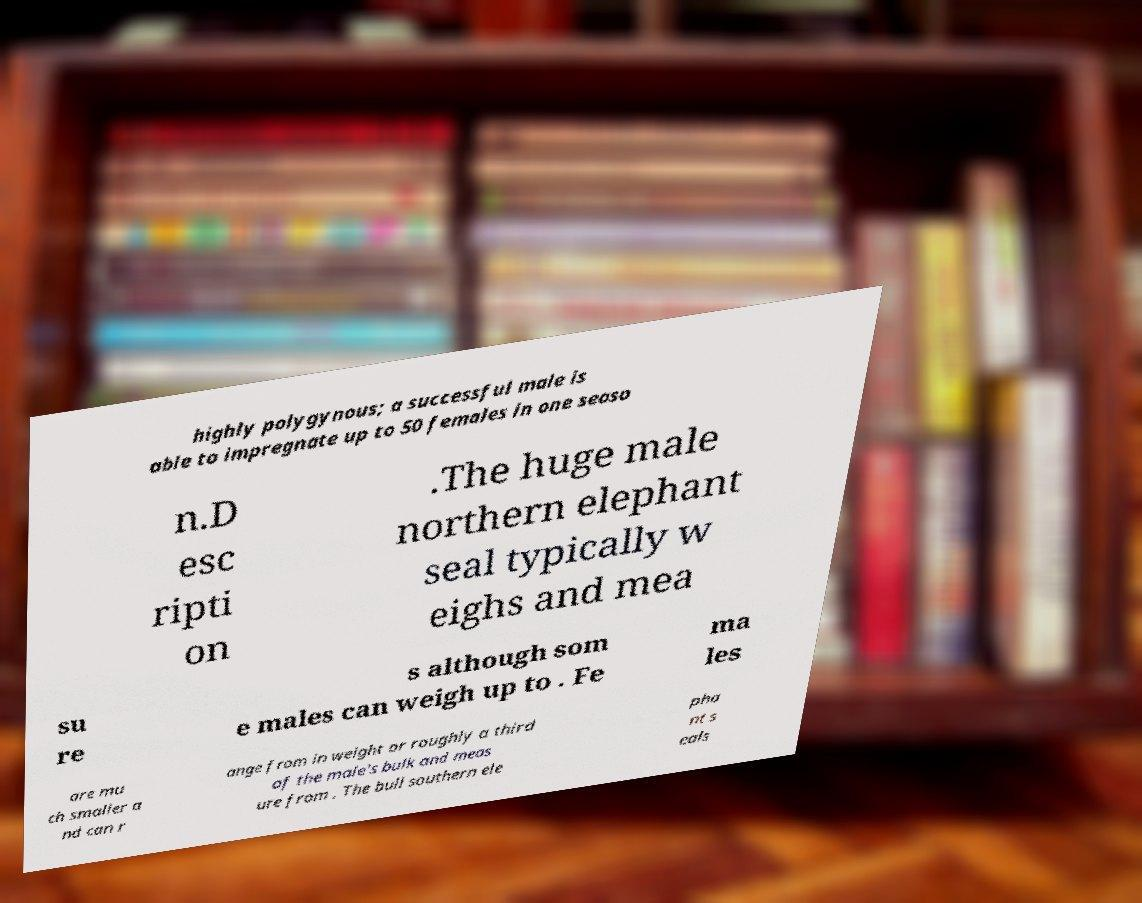Please identify and transcribe the text found in this image. highly polygynous; a successful male is able to impregnate up to 50 females in one seaso n.D esc ripti on .The huge male northern elephant seal typically w eighs and mea su re s although som e males can weigh up to . Fe ma les are mu ch smaller a nd can r ange from in weight or roughly a third of the male's bulk and meas ure from . The bull southern ele pha nt s eals 